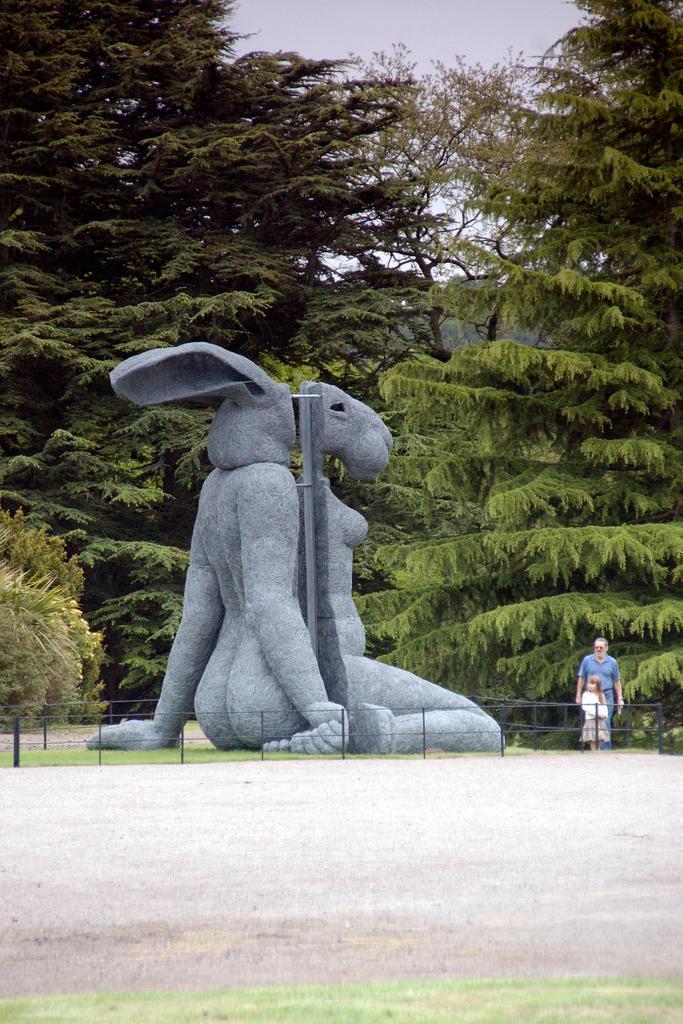How would you summarize this image in a sentence or two? In this image I can see the road. I can see the statue. On the right side, I can see two people. In the background, I can see the trees and the sky. 